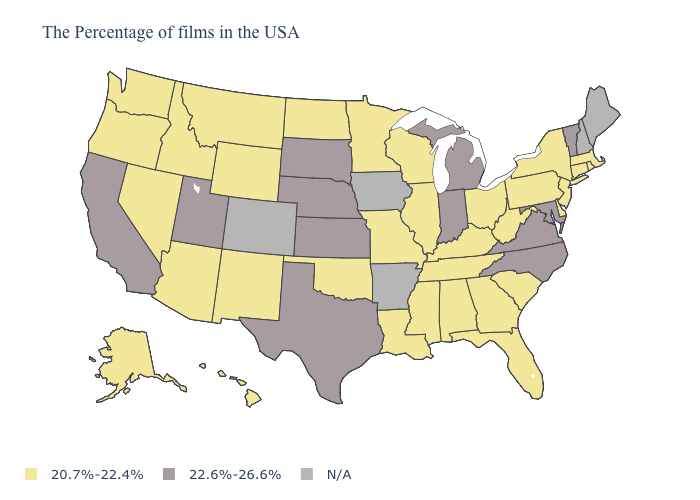What is the value of Florida?
Quick response, please. 20.7%-22.4%. What is the value of New Mexico?
Be succinct. 20.7%-22.4%. Does the first symbol in the legend represent the smallest category?
Concise answer only. Yes. What is the value of Wyoming?
Keep it brief. 20.7%-22.4%. Name the states that have a value in the range N/A?
Keep it brief. Maine, New Hampshire, Arkansas, Iowa, Colorado. What is the value of Louisiana?
Write a very short answer. 20.7%-22.4%. What is the highest value in states that border Vermont?
Answer briefly. 20.7%-22.4%. Does Missouri have the lowest value in the MidWest?
Give a very brief answer. Yes. What is the value of North Dakota?
Be succinct. 20.7%-22.4%. What is the value of Virginia?
Keep it brief. 22.6%-26.6%. Which states have the highest value in the USA?
Concise answer only. Vermont, Maryland, Virginia, North Carolina, Michigan, Indiana, Kansas, Nebraska, Texas, South Dakota, Utah, California. Does Hawaii have the lowest value in the West?
Write a very short answer. Yes. Name the states that have a value in the range N/A?
Write a very short answer. Maine, New Hampshire, Arkansas, Iowa, Colorado. 